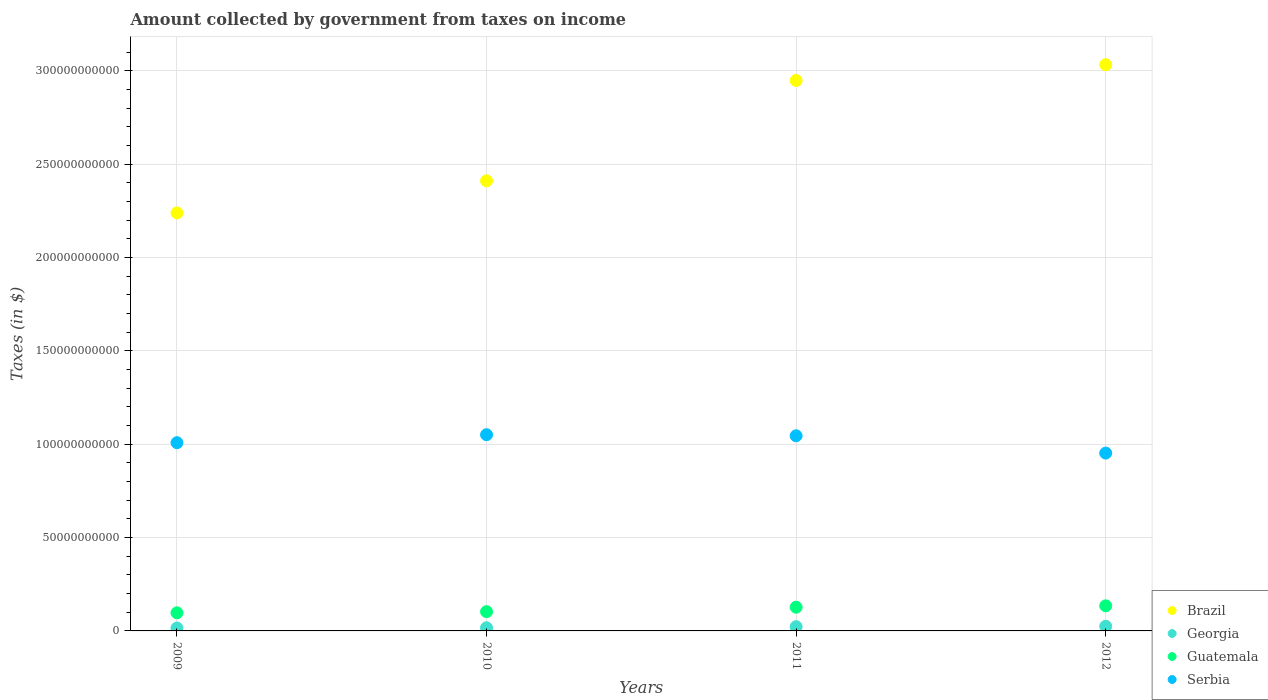How many different coloured dotlines are there?
Your response must be concise. 4. Is the number of dotlines equal to the number of legend labels?
Provide a succinct answer. Yes. What is the amount collected by government from taxes on income in Guatemala in 2009?
Ensure brevity in your answer.  9.71e+09. Across all years, what is the maximum amount collected by government from taxes on income in Brazil?
Provide a succinct answer. 3.03e+11. Across all years, what is the minimum amount collected by government from taxes on income in Guatemala?
Your answer should be very brief. 9.71e+09. In which year was the amount collected by government from taxes on income in Serbia maximum?
Provide a succinct answer. 2010. What is the total amount collected by government from taxes on income in Guatemala in the graph?
Offer a very short reply. 4.62e+1. What is the difference between the amount collected by government from taxes on income in Guatemala in 2011 and that in 2012?
Keep it short and to the point. -7.47e+08. What is the difference between the amount collected by government from taxes on income in Georgia in 2011 and the amount collected by government from taxes on income in Serbia in 2010?
Keep it short and to the point. -1.03e+11. What is the average amount collected by government from taxes on income in Georgia per year?
Make the answer very short. 2.01e+09. In the year 2010, what is the difference between the amount collected by government from taxes on income in Serbia and amount collected by government from taxes on income in Guatemala?
Make the answer very short. 9.47e+1. In how many years, is the amount collected by government from taxes on income in Brazil greater than 110000000000 $?
Provide a succinct answer. 4. What is the ratio of the amount collected by government from taxes on income in Brazil in 2010 to that in 2012?
Your response must be concise. 0.8. Is the difference between the amount collected by government from taxes on income in Serbia in 2010 and 2011 greater than the difference between the amount collected by government from taxes on income in Guatemala in 2010 and 2011?
Your answer should be very brief. Yes. What is the difference between the highest and the second highest amount collected by government from taxes on income in Guatemala?
Give a very brief answer. 7.47e+08. What is the difference between the highest and the lowest amount collected by government from taxes on income in Brazil?
Give a very brief answer. 7.93e+1. Is the sum of the amount collected by government from taxes on income in Brazil in 2009 and 2011 greater than the maximum amount collected by government from taxes on income in Guatemala across all years?
Ensure brevity in your answer.  Yes. Is it the case that in every year, the sum of the amount collected by government from taxes on income in Guatemala and amount collected by government from taxes on income in Brazil  is greater than the amount collected by government from taxes on income in Georgia?
Give a very brief answer. Yes. Does the amount collected by government from taxes on income in Serbia monotonically increase over the years?
Keep it short and to the point. No. Is the amount collected by government from taxes on income in Brazil strictly less than the amount collected by government from taxes on income in Guatemala over the years?
Offer a very short reply. No. How many dotlines are there?
Provide a short and direct response. 4. Does the graph contain any zero values?
Provide a succinct answer. No. What is the title of the graph?
Your answer should be compact. Amount collected by government from taxes on income. What is the label or title of the X-axis?
Make the answer very short. Years. What is the label or title of the Y-axis?
Ensure brevity in your answer.  Taxes (in $). What is the Taxes (in $) of Brazil in 2009?
Ensure brevity in your answer.  2.24e+11. What is the Taxes (in $) of Georgia in 2009?
Offer a very short reply. 1.57e+09. What is the Taxes (in $) of Guatemala in 2009?
Offer a terse response. 9.71e+09. What is the Taxes (in $) of Serbia in 2009?
Ensure brevity in your answer.  1.01e+11. What is the Taxes (in $) in Brazil in 2010?
Give a very brief answer. 2.41e+11. What is the Taxes (in $) in Georgia in 2010?
Make the answer very short. 1.70e+09. What is the Taxes (in $) of Guatemala in 2010?
Give a very brief answer. 1.03e+1. What is the Taxes (in $) in Serbia in 2010?
Offer a very short reply. 1.05e+11. What is the Taxes (in $) in Brazil in 2011?
Keep it short and to the point. 2.95e+11. What is the Taxes (in $) in Georgia in 2011?
Offer a very short reply. 2.27e+09. What is the Taxes (in $) of Guatemala in 2011?
Provide a succinct answer. 1.27e+1. What is the Taxes (in $) in Serbia in 2011?
Provide a succinct answer. 1.04e+11. What is the Taxes (in $) in Brazil in 2012?
Give a very brief answer. 3.03e+11. What is the Taxes (in $) in Georgia in 2012?
Keep it short and to the point. 2.49e+09. What is the Taxes (in $) in Guatemala in 2012?
Provide a succinct answer. 1.34e+1. What is the Taxes (in $) in Serbia in 2012?
Keep it short and to the point. 9.52e+1. Across all years, what is the maximum Taxes (in $) in Brazil?
Keep it short and to the point. 3.03e+11. Across all years, what is the maximum Taxes (in $) in Georgia?
Keep it short and to the point. 2.49e+09. Across all years, what is the maximum Taxes (in $) of Guatemala?
Your answer should be very brief. 1.34e+1. Across all years, what is the maximum Taxes (in $) in Serbia?
Ensure brevity in your answer.  1.05e+11. Across all years, what is the minimum Taxes (in $) of Brazil?
Provide a succinct answer. 2.24e+11. Across all years, what is the minimum Taxes (in $) in Georgia?
Provide a short and direct response. 1.57e+09. Across all years, what is the minimum Taxes (in $) in Guatemala?
Keep it short and to the point. 9.71e+09. Across all years, what is the minimum Taxes (in $) of Serbia?
Offer a very short reply. 9.52e+1. What is the total Taxes (in $) in Brazil in the graph?
Provide a succinct answer. 1.06e+12. What is the total Taxes (in $) in Georgia in the graph?
Keep it short and to the point. 8.02e+09. What is the total Taxes (in $) in Guatemala in the graph?
Your answer should be compact. 4.62e+1. What is the total Taxes (in $) in Serbia in the graph?
Your answer should be very brief. 4.06e+11. What is the difference between the Taxes (in $) of Brazil in 2009 and that in 2010?
Your answer should be very brief. -1.72e+1. What is the difference between the Taxes (in $) of Georgia in 2009 and that in 2010?
Ensure brevity in your answer.  -1.24e+08. What is the difference between the Taxes (in $) of Guatemala in 2009 and that in 2010?
Your answer should be compact. -6.13e+08. What is the difference between the Taxes (in $) of Serbia in 2009 and that in 2010?
Your response must be concise. -4.26e+09. What is the difference between the Taxes (in $) of Brazil in 2009 and that in 2011?
Ensure brevity in your answer.  -7.09e+1. What is the difference between the Taxes (in $) in Georgia in 2009 and that in 2011?
Your answer should be very brief. -7.01e+08. What is the difference between the Taxes (in $) of Guatemala in 2009 and that in 2011?
Offer a very short reply. -2.99e+09. What is the difference between the Taxes (in $) in Serbia in 2009 and that in 2011?
Provide a succinct answer. -3.69e+09. What is the difference between the Taxes (in $) in Brazil in 2009 and that in 2012?
Keep it short and to the point. -7.93e+1. What is the difference between the Taxes (in $) of Georgia in 2009 and that in 2012?
Offer a terse response. -9.16e+08. What is the difference between the Taxes (in $) of Guatemala in 2009 and that in 2012?
Ensure brevity in your answer.  -3.74e+09. What is the difference between the Taxes (in $) in Serbia in 2009 and that in 2012?
Your answer should be very brief. 5.57e+09. What is the difference between the Taxes (in $) in Brazil in 2010 and that in 2011?
Your answer should be compact. -5.37e+1. What is the difference between the Taxes (in $) in Georgia in 2010 and that in 2011?
Your answer should be very brief. -5.77e+08. What is the difference between the Taxes (in $) in Guatemala in 2010 and that in 2011?
Provide a succinct answer. -2.38e+09. What is the difference between the Taxes (in $) of Serbia in 2010 and that in 2011?
Your answer should be very brief. 5.70e+08. What is the difference between the Taxes (in $) of Brazil in 2010 and that in 2012?
Offer a very short reply. -6.22e+1. What is the difference between the Taxes (in $) in Georgia in 2010 and that in 2012?
Ensure brevity in your answer.  -7.92e+08. What is the difference between the Taxes (in $) in Guatemala in 2010 and that in 2012?
Ensure brevity in your answer.  -3.12e+09. What is the difference between the Taxes (in $) of Serbia in 2010 and that in 2012?
Provide a short and direct response. 9.83e+09. What is the difference between the Taxes (in $) of Brazil in 2011 and that in 2012?
Give a very brief answer. -8.43e+09. What is the difference between the Taxes (in $) in Georgia in 2011 and that in 2012?
Offer a very short reply. -2.16e+08. What is the difference between the Taxes (in $) in Guatemala in 2011 and that in 2012?
Make the answer very short. -7.47e+08. What is the difference between the Taxes (in $) of Serbia in 2011 and that in 2012?
Make the answer very short. 9.26e+09. What is the difference between the Taxes (in $) of Brazil in 2009 and the Taxes (in $) of Georgia in 2010?
Your answer should be compact. 2.22e+11. What is the difference between the Taxes (in $) of Brazil in 2009 and the Taxes (in $) of Guatemala in 2010?
Ensure brevity in your answer.  2.14e+11. What is the difference between the Taxes (in $) in Brazil in 2009 and the Taxes (in $) in Serbia in 2010?
Keep it short and to the point. 1.19e+11. What is the difference between the Taxes (in $) in Georgia in 2009 and the Taxes (in $) in Guatemala in 2010?
Your answer should be very brief. -8.75e+09. What is the difference between the Taxes (in $) of Georgia in 2009 and the Taxes (in $) of Serbia in 2010?
Offer a very short reply. -1.03e+11. What is the difference between the Taxes (in $) of Guatemala in 2009 and the Taxes (in $) of Serbia in 2010?
Provide a short and direct response. -9.54e+1. What is the difference between the Taxes (in $) of Brazil in 2009 and the Taxes (in $) of Georgia in 2011?
Ensure brevity in your answer.  2.22e+11. What is the difference between the Taxes (in $) of Brazil in 2009 and the Taxes (in $) of Guatemala in 2011?
Your response must be concise. 2.11e+11. What is the difference between the Taxes (in $) in Brazil in 2009 and the Taxes (in $) in Serbia in 2011?
Offer a terse response. 1.19e+11. What is the difference between the Taxes (in $) of Georgia in 2009 and the Taxes (in $) of Guatemala in 2011?
Make the answer very short. -1.11e+1. What is the difference between the Taxes (in $) of Georgia in 2009 and the Taxes (in $) of Serbia in 2011?
Provide a succinct answer. -1.03e+11. What is the difference between the Taxes (in $) in Guatemala in 2009 and the Taxes (in $) in Serbia in 2011?
Offer a very short reply. -9.48e+1. What is the difference between the Taxes (in $) of Brazil in 2009 and the Taxes (in $) of Georgia in 2012?
Provide a succinct answer. 2.21e+11. What is the difference between the Taxes (in $) of Brazil in 2009 and the Taxes (in $) of Guatemala in 2012?
Keep it short and to the point. 2.10e+11. What is the difference between the Taxes (in $) of Brazil in 2009 and the Taxes (in $) of Serbia in 2012?
Provide a succinct answer. 1.29e+11. What is the difference between the Taxes (in $) in Georgia in 2009 and the Taxes (in $) in Guatemala in 2012?
Offer a terse response. -1.19e+1. What is the difference between the Taxes (in $) in Georgia in 2009 and the Taxes (in $) in Serbia in 2012?
Offer a terse response. -9.37e+1. What is the difference between the Taxes (in $) in Guatemala in 2009 and the Taxes (in $) in Serbia in 2012?
Your response must be concise. -8.55e+1. What is the difference between the Taxes (in $) of Brazil in 2010 and the Taxes (in $) of Georgia in 2011?
Offer a very short reply. 2.39e+11. What is the difference between the Taxes (in $) of Brazil in 2010 and the Taxes (in $) of Guatemala in 2011?
Provide a short and direct response. 2.28e+11. What is the difference between the Taxes (in $) of Brazil in 2010 and the Taxes (in $) of Serbia in 2011?
Give a very brief answer. 1.37e+11. What is the difference between the Taxes (in $) in Georgia in 2010 and the Taxes (in $) in Guatemala in 2011?
Offer a terse response. -1.10e+1. What is the difference between the Taxes (in $) in Georgia in 2010 and the Taxes (in $) in Serbia in 2011?
Provide a short and direct response. -1.03e+11. What is the difference between the Taxes (in $) in Guatemala in 2010 and the Taxes (in $) in Serbia in 2011?
Offer a terse response. -9.42e+1. What is the difference between the Taxes (in $) in Brazil in 2010 and the Taxes (in $) in Georgia in 2012?
Offer a very short reply. 2.39e+11. What is the difference between the Taxes (in $) of Brazil in 2010 and the Taxes (in $) of Guatemala in 2012?
Offer a very short reply. 2.28e+11. What is the difference between the Taxes (in $) in Brazil in 2010 and the Taxes (in $) in Serbia in 2012?
Offer a terse response. 1.46e+11. What is the difference between the Taxes (in $) of Georgia in 2010 and the Taxes (in $) of Guatemala in 2012?
Your response must be concise. -1.17e+1. What is the difference between the Taxes (in $) in Georgia in 2010 and the Taxes (in $) in Serbia in 2012?
Provide a succinct answer. -9.35e+1. What is the difference between the Taxes (in $) in Guatemala in 2010 and the Taxes (in $) in Serbia in 2012?
Provide a short and direct response. -8.49e+1. What is the difference between the Taxes (in $) in Brazil in 2011 and the Taxes (in $) in Georgia in 2012?
Offer a terse response. 2.92e+11. What is the difference between the Taxes (in $) in Brazil in 2011 and the Taxes (in $) in Guatemala in 2012?
Make the answer very short. 2.81e+11. What is the difference between the Taxes (in $) of Brazil in 2011 and the Taxes (in $) of Serbia in 2012?
Your answer should be compact. 2.00e+11. What is the difference between the Taxes (in $) in Georgia in 2011 and the Taxes (in $) in Guatemala in 2012?
Offer a very short reply. -1.12e+1. What is the difference between the Taxes (in $) in Georgia in 2011 and the Taxes (in $) in Serbia in 2012?
Give a very brief answer. -9.30e+1. What is the difference between the Taxes (in $) in Guatemala in 2011 and the Taxes (in $) in Serbia in 2012?
Give a very brief answer. -8.25e+1. What is the average Taxes (in $) of Brazil per year?
Provide a short and direct response. 2.66e+11. What is the average Taxes (in $) of Georgia per year?
Your answer should be very brief. 2.01e+09. What is the average Taxes (in $) of Guatemala per year?
Your answer should be very brief. 1.15e+1. What is the average Taxes (in $) in Serbia per year?
Provide a short and direct response. 1.01e+11. In the year 2009, what is the difference between the Taxes (in $) of Brazil and Taxes (in $) of Georgia?
Provide a succinct answer. 2.22e+11. In the year 2009, what is the difference between the Taxes (in $) in Brazil and Taxes (in $) in Guatemala?
Ensure brevity in your answer.  2.14e+11. In the year 2009, what is the difference between the Taxes (in $) of Brazil and Taxes (in $) of Serbia?
Offer a terse response. 1.23e+11. In the year 2009, what is the difference between the Taxes (in $) of Georgia and Taxes (in $) of Guatemala?
Give a very brief answer. -8.13e+09. In the year 2009, what is the difference between the Taxes (in $) of Georgia and Taxes (in $) of Serbia?
Give a very brief answer. -9.92e+1. In the year 2009, what is the difference between the Taxes (in $) in Guatemala and Taxes (in $) in Serbia?
Your response must be concise. -9.11e+1. In the year 2010, what is the difference between the Taxes (in $) in Brazil and Taxes (in $) in Georgia?
Give a very brief answer. 2.39e+11. In the year 2010, what is the difference between the Taxes (in $) of Brazil and Taxes (in $) of Guatemala?
Give a very brief answer. 2.31e+11. In the year 2010, what is the difference between the Taxes (in $) of Brazil and Taxes (in $) of Serbia?
Provide a short and direct response. 1.36e+11. In the year 2010, what is the difference between the Taxes (in $) of Georgia and Taxes (in $) of Guatemala?
Your response must be concise. -8.62e+09. In the year 2010, what is the difference between the Taxes (in $) of Georgia and Taxes (in $) of Serbia?
Provide a succinct answer. -1.03e+11. In the year 2010, what is the difference between the Taxes (in $) in Guatemala and Taxes (in $) in Serbia?
Provide a short and direct response. -9.47e+1. In the year 2011, what is the difference between the Taxes (in $) of Brazil and Taxes (in $) of Georgia?
Ensure brevity in your answer.  2.92e+11. In the year 2011, what is the difference between the Taxes (in $) of Brazil and Taxes (in $) of Guatemala?
Provide a short and direct response. 2.82e+11. In the year 2011, what is the difference between the Taxes (in $) of Brazil and Taxes (in $) of Serbia?
Make the answer very short. 1.90e+11. In the year 2011, what is the difference between the Taxes (in $) of Georgia and Taxes (in $) of Guatemala?
Your answer should be very brief. -1.04e+1. In the year 2011, what is the difference between the Taxes (in $) of Georgia and Taxes (in $) of Serbia?
Give a very brief answer. -1.02e+11. In the year 2011, what is the difference between the Taxes (in $) of Guatemala and Taxes (in $) of Serbia?
Give a very brief answer. -9.18e+1. In the year 2012, what is the difference between the Taxes (in $) of Brazil and Taxes (in $) of Georgia?
Provide a succinct answer. 3.01e+11. In the year 2012, what is the difference between the Taxes (in $) in Brazil and Taxes (in $) in Guatemala?
Ensure brevity in your answer.  2.90e+11. In the year 2012, what is the difference between the Taxes (in $) in Brazil and Taxes (in $) in Serbia?
Your response must be concise. 2.08e+11. In the year 2012, what is the difference between the Taxes (in $) in Georgia and Taxes (in $) in Guatemala?
Ensure brevity in your answer.  -1.10e+1. In the year 2012, what is the difference between the Taxes (in $) of Georgia and Taxes (in $) of Serbia?
Your answer should be compact. -9.27e+1. In the year 2012, what is the difference between the Taxes (in $) of Guatemala and Taxes (in $) of Serbia?
Your response must be concise. -8.18e+1. What is the ratio of the Taxes (in $) of Brazil in 2009 to that in 2010?
Offer a very short reply. 0.93. What is the ratio of the Taxes (in $) of Georgia in 2009 to that in 2010?
Your answer should be compact. 0.93. What is the ratio of the Taxes (in $) in Guatemala in 2009 to that in 2010?
Keep it short and to the point. 0.94. What is the ratio of the Taxes (in $) of Serbia in 2009 to that in 2010?
Your response must be concise. 0.96. What is the ratio of the Taxes (in $) of Brazil in 2009 to that in 2011?
Provide a short and direct response. 0.76. What is the ratio of the Taxes (in $) in Georgia in 2009 to that in 2011?
Make the answer very short. 0.69. What is the ratio of the Taxes (in $) in Guatemala in 2009 to that in 2011?
Keep it short and to the point. 0.76. What is the ratio of the Taxes (in $) in Serbia in 2009 to that in 2011?
Keep it short and to the point. 0.96. What is the ratio of the Taxes (in $) of Brazil in 2009 to that in 2012?
Provide a succinct answer. 0.74. What is the ratio of the Taxes (in $) of Georgia in 2009 to that in 2012?
Your response must be concise. 0.63. What is the ratio of the Taxes (in $) in Guatemala in 2009 to that in 2012?
Keep it short and to the point. 0.72. What is the ratio of the Taxes (in $) of Serbia in 2009 to that in 2012?
Your answer should be very brief. 1.06. What is the ratio of the Taxes (in $) of Brazil in 2010 to that in 2011?
Your answer should be very brief. 0.82. What is the ratio of the Taxes (in $) in Georgia in 2010 to that in 2011?
Offer a very short reply. 0.75. What is the ratio of the Taxes (in $) in Guatemala in 2010 to that in 2011?
Ensure brevity in your answer.  0.81. What is the ratio of the Taxes (in $) of Brazil in 2010 to that in 2012?
Keep it short and to the point. 0.8. What is the ratio of the Taxes (in $) in Georgia in 2010 to that in 2012?
Give a very brief answer. 0.68. What is the ratio of the Taxes (in $) of Guatemala in 2010 to that in 2012?
Your answer should be compact. 0.77. What is the ratio of the Taxes (in $) of Serbia in 2010 to that in 2012?
Give a very brief answer. 1.1. What is the ratio of the Taxes (in $) of Brazil in 2011 to that in 2012?
Offer a very short reply. 0.97. What is the ratio of the Taxes (in $) in Georgia in 2011 to that in 2012?
Offer a terse response. 0.91. What is the ratio of the Taxes (in $) in Guatemala in 2011 to that in 2012?
Your response must be concise. 0.94. What is the ratio of the Taxes (in $) of Serbia in 2011 to that in 2012?
Make the answer very short. 1.1. What is the difference between the highest and the second highest Taxes (in $) in Brazil?
Keep it short and to the point. 8.43e+09. What is the difference between the highest and the second highest Taxes (in $) in Georgia?
Your answer should be very brief. 2.16e+08. What is the difference between the highest and the second highest Taxes (in $) of Guatemala?
Provide a short and direct response. 7.47e+08. What is the difference between the highest and the second highest Taxes (in $) of Serbia?
Your response must be concise. 5.70e+08. What is the difference between the highest and the lowest Taxes (in $) in Brazil?
Provide a short and direct response. 7.93e+1. What is the difference between the highest and the lowest Taxes (in $) of Georgia?
Your response must be concise. 9.16e+08. What is the difference between the highest and the lowest Taxes (in $) of Guatemala?
Offer a terse response. 3.74e+09. What is the difference between the highest and the lowest Taxes (in $) in Serbia?
Make the answer very short. 9.83e+09. 